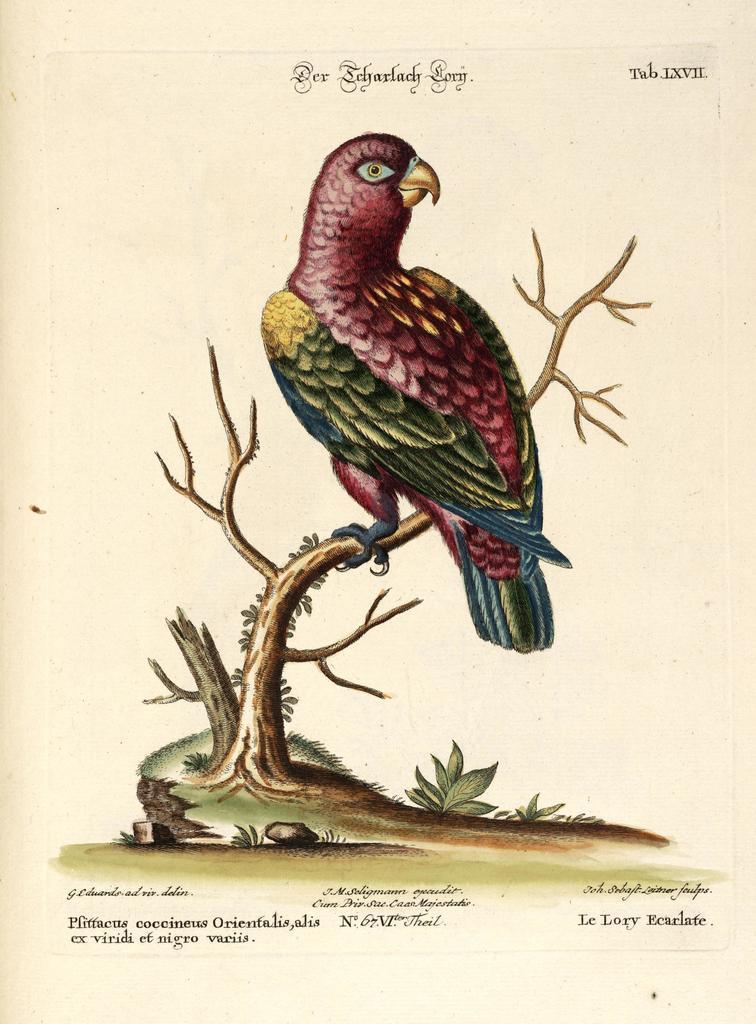Can you describe this image briefly? In this image we can see a poster, on the poster, we can see a bird on the tree and also we can see some text. 